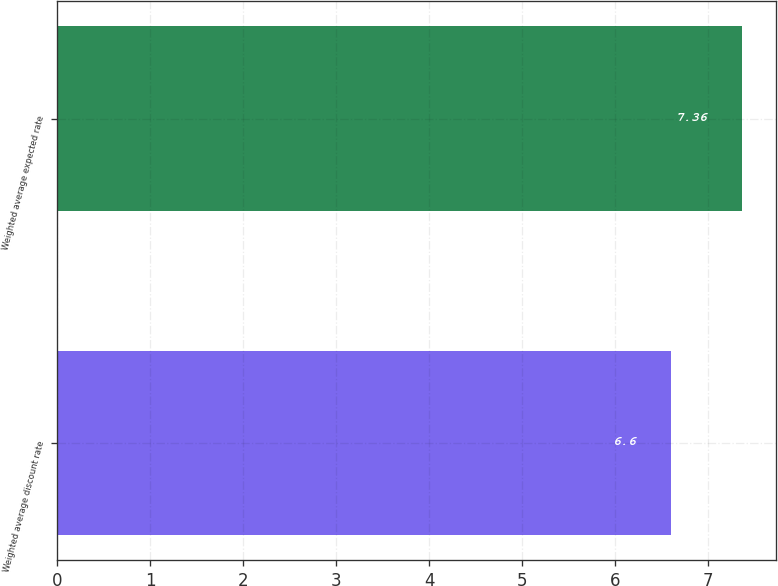<chart> <loc_0><loc_0><loc_500><loc_500><bar_chart><fcel>Weighted average discount rate<fcel>Weighted average expected rate<nl><fcel>6.6<fcel>7.36<nl></chart> 